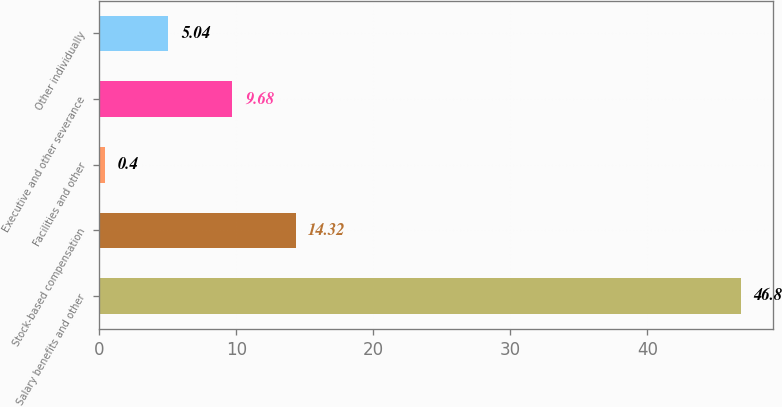Convert chart. <chart><loc_0><loc_0><loc_500><loc_500><bar_chart><fcel>Salary benefits and other<fcel>Stock-based compensation<fcel>Facilities and other<fcel>Executive and other severance<fcel>Other individually<nl><fcel>46.8<fcel>14.32<fcel>0.4<fcel>9.68<fcel>5.04<nl></chart> 